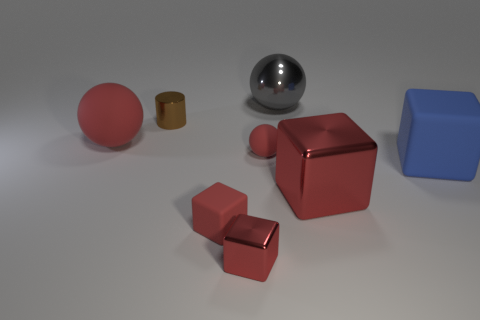Is the color of the tiny rubber ball the same as the tiny matte cube?
Offer a very short reply. Yes. Is the color of the thing that is on the left side of the small brown thing the same as the small rubber sphere?
Ensure brevity in your answer.  Yes. Is there a tiny brown thing behind the tiny red rubber thing that is in front of the small matte object that is to the right of the small red metallic thing?
Give a very brief answer. Yes. What shape is the tiny red thing that is both on the right side of the tiny red rubber cube and behind the small shiny cube?
Provide a succinct answer. Sphere. Is there a small ball of the same color as the small rubber block?
Your answer should be compact. Yes. What color is the matte sphere that is behind the small red thing behind the small red matte block?
Keep it short and to the point. Red. How big is the red metal block that is left of the small red matte object behind the large rubber thing that is on the right side of the small cylinder?
Offer a very short reply. Small. Is the material of the big blue block the same as the big ball on the right side of the brown metal cylinder?
Make the answer very short. No. There is a brown cylinder that is made of the same material as the gray object; what size is it?
Make the answer very short. Small. Is there another big thing that has the same shape as the big gray metallic thing?
Offer a terse response. Yes. 